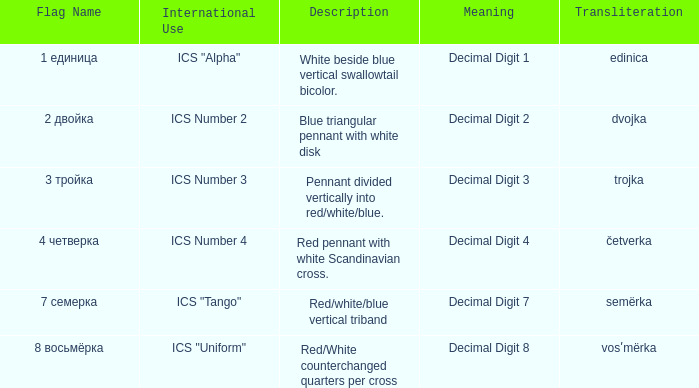What is the international use of the 1 единица flag? ICS "Alpha". 